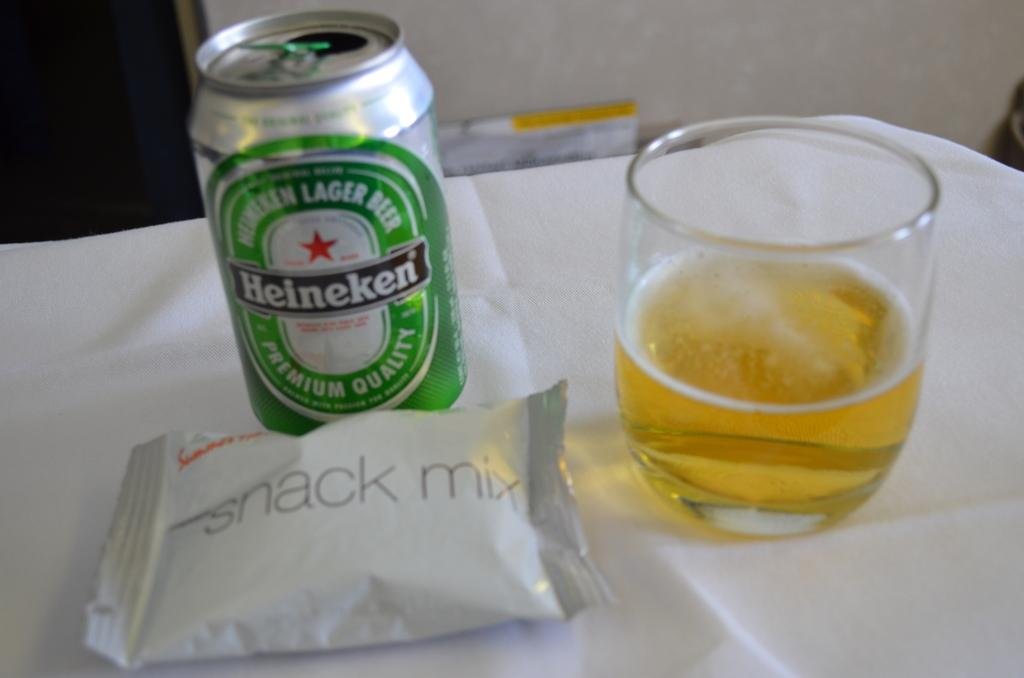<image>
Describe the image concisely. Can of Heineken beer and Snack mix on a table. 